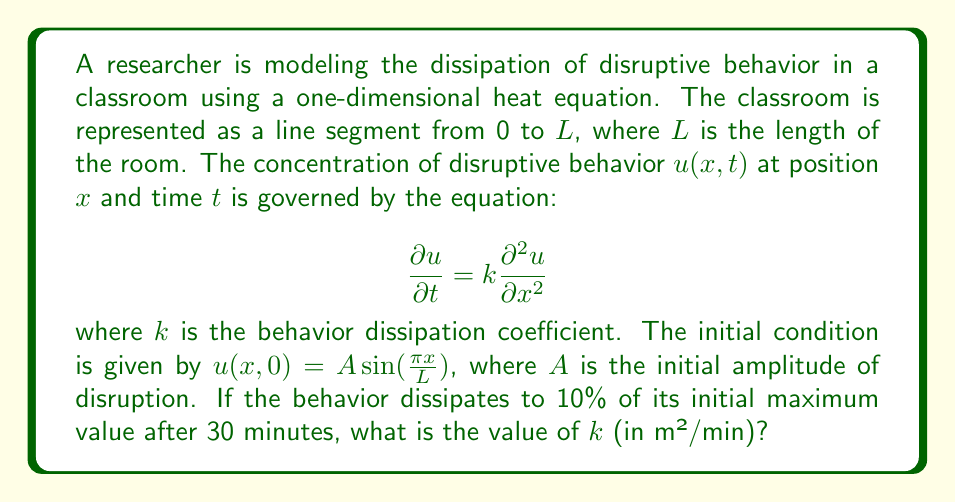Can you answer this question? Let's approach this step-by-step:

1) The general solution to the one-dimensional heat equation with the given initial condition is:

   $$u(x,t) = A\sin(\frac{\pi x}{L})e^{-\frac{k\pi^2}{L^2}t}$$

2) We're told that after 30 minutes, the behavior dissipates to 10% of its initial maximum value. This means:

   $$\frac{u(x,30)}{u(x,0)} = 0.1$$

3) Substituting the general solution:

   $$\frac{A\sin(\frac{\pi x}{L})e^{-\frac{k\pi^2}{L^2}(30)}}{A\sin(\frac{\pi x}{L})} = 0.1$$

4) The $A\sin(\frac{\pi x}{L})$ terms cancel out:

   $$e^{-\frac{k\pi^2}{L^2}(30)} = 0.1$$

5) Taking the natural log of both sides:

   $$-\frac{k\pi^2}{L^2}(30) = \ln(0.1)$$

6) Solving for k:

   $$k = -\frac{L^2\ln(0.1)}{30\pi^2}$$

7) We don't know the value of L, but we can simplify this to:

   $$k \approx 0.00243 L^2$$

This gives us k in terms of L². Since k is asked for in m²/min, L must be in meters for the units to work out correctly.
Answer: $k \approx 0.00243 L^2$ m²/min, where L is the length of the classroom in meters. 